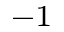<formula> <loc_0><loc_0><loc_500><loc_500>^ { - 1 }</formula> 